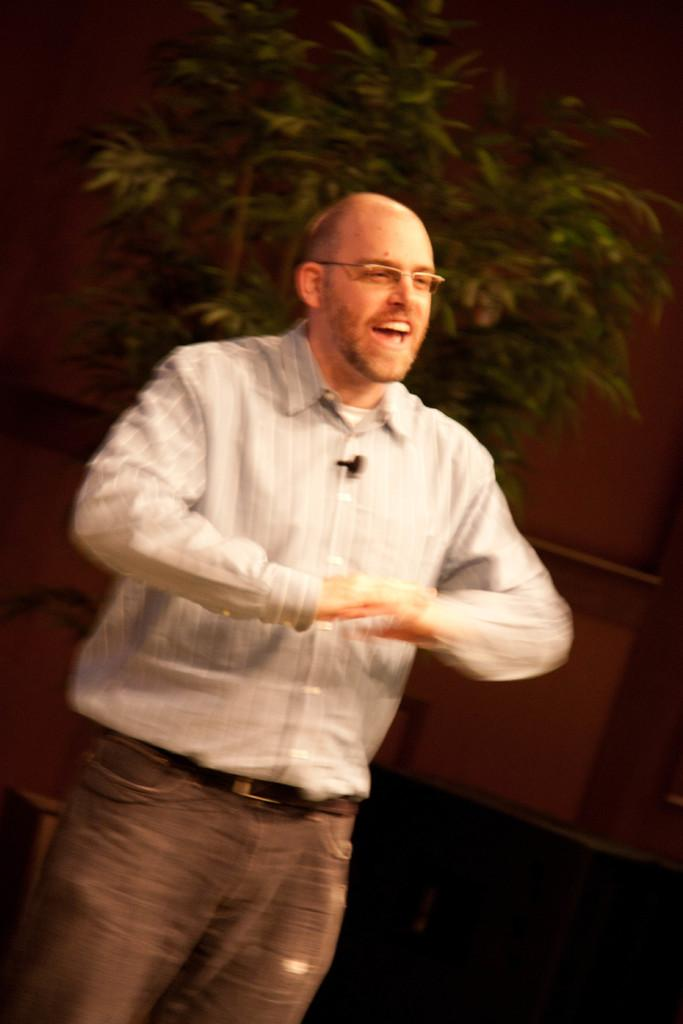Who is the main subject in the image? There is a man in the image. What is the man doing in the image? The man is explaining something. What can be seen behind the man in the image? There is a house plant and a wall behind the man. What type of nation is depicted in the image? There is no nation depicted in the image; it features a man explaining something with a house plant and a wall behind him. How many trees are visible in the image? There are no trees visible in the image. 